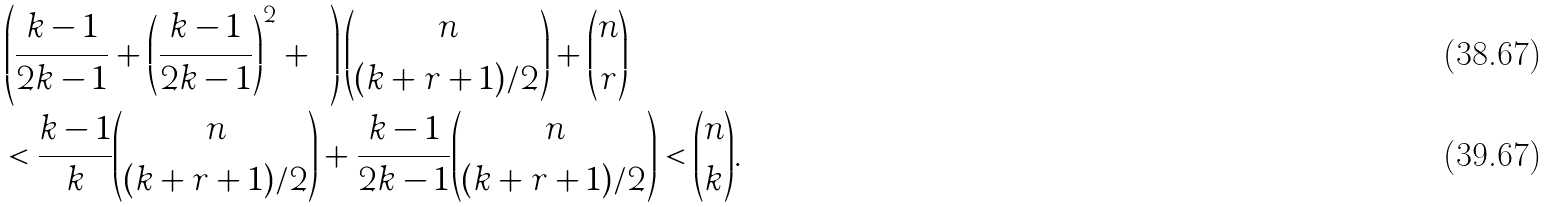<formula> <loc_0><loc_0><loc_500><loc_500>& \left ( \frac { k - 1 } { 2 k - 1 } + \left ( \frac { k - 1 } { 2 k - 1 } \right ) ^ { 2 } + \cdots \right ) \binom { n } { ( k + r + 1 ) / 2 } + \binom { n } { r } \\ & < \frac { k - 1 } { k } \binom { n } { ( k + r + 1 ) / 2 } + \frac { k - 1 } { 2 k - 1 } \binom { n } { ( k + r + 1 ) / 2 } < \binom { n } { k } .</formula> 